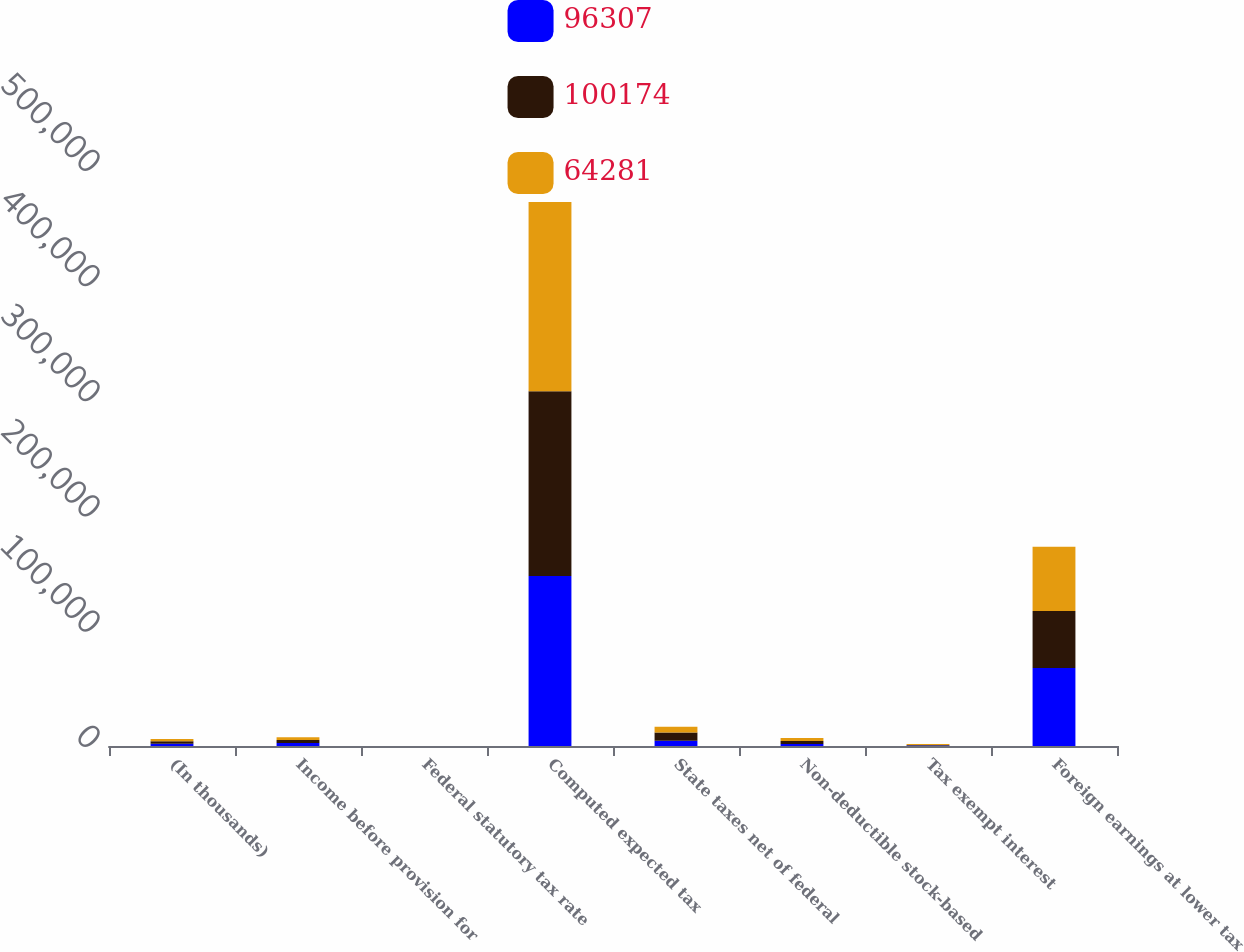Convert chart to OTSL. <chart><loc_0><loc_0><loc_500><loc_500><stacked_bar_chart><ecel><fcel>(In thousands)<fcel>Income before provision for<fcel>Federal statutory tax rate<fcel>Computed expected tax<fcel>State taxes net of federal<fcel>Non-deductible stock-based<fcel>Tax exempt interest<fcel>Foreign earnings at lower tax<nl><fcel>96307<fcel>2010<fcel>2550<fcel>35<fcel>147618<fcel>4527<fcel>1813<fcel>396<fcel>67651<nl><fcel>100174<fcel>2009<fcel>2550<fcel>35<fcel>160309<fcel>7292<fcel>2550<fcel>567<fcel>49446<nl><fcel>64281<fcel>2008<fcel>2550<fcel>35<fcel>164321<fcel>4970<fcel>2676<fcel>721<fcel>55949<nl></chart> 